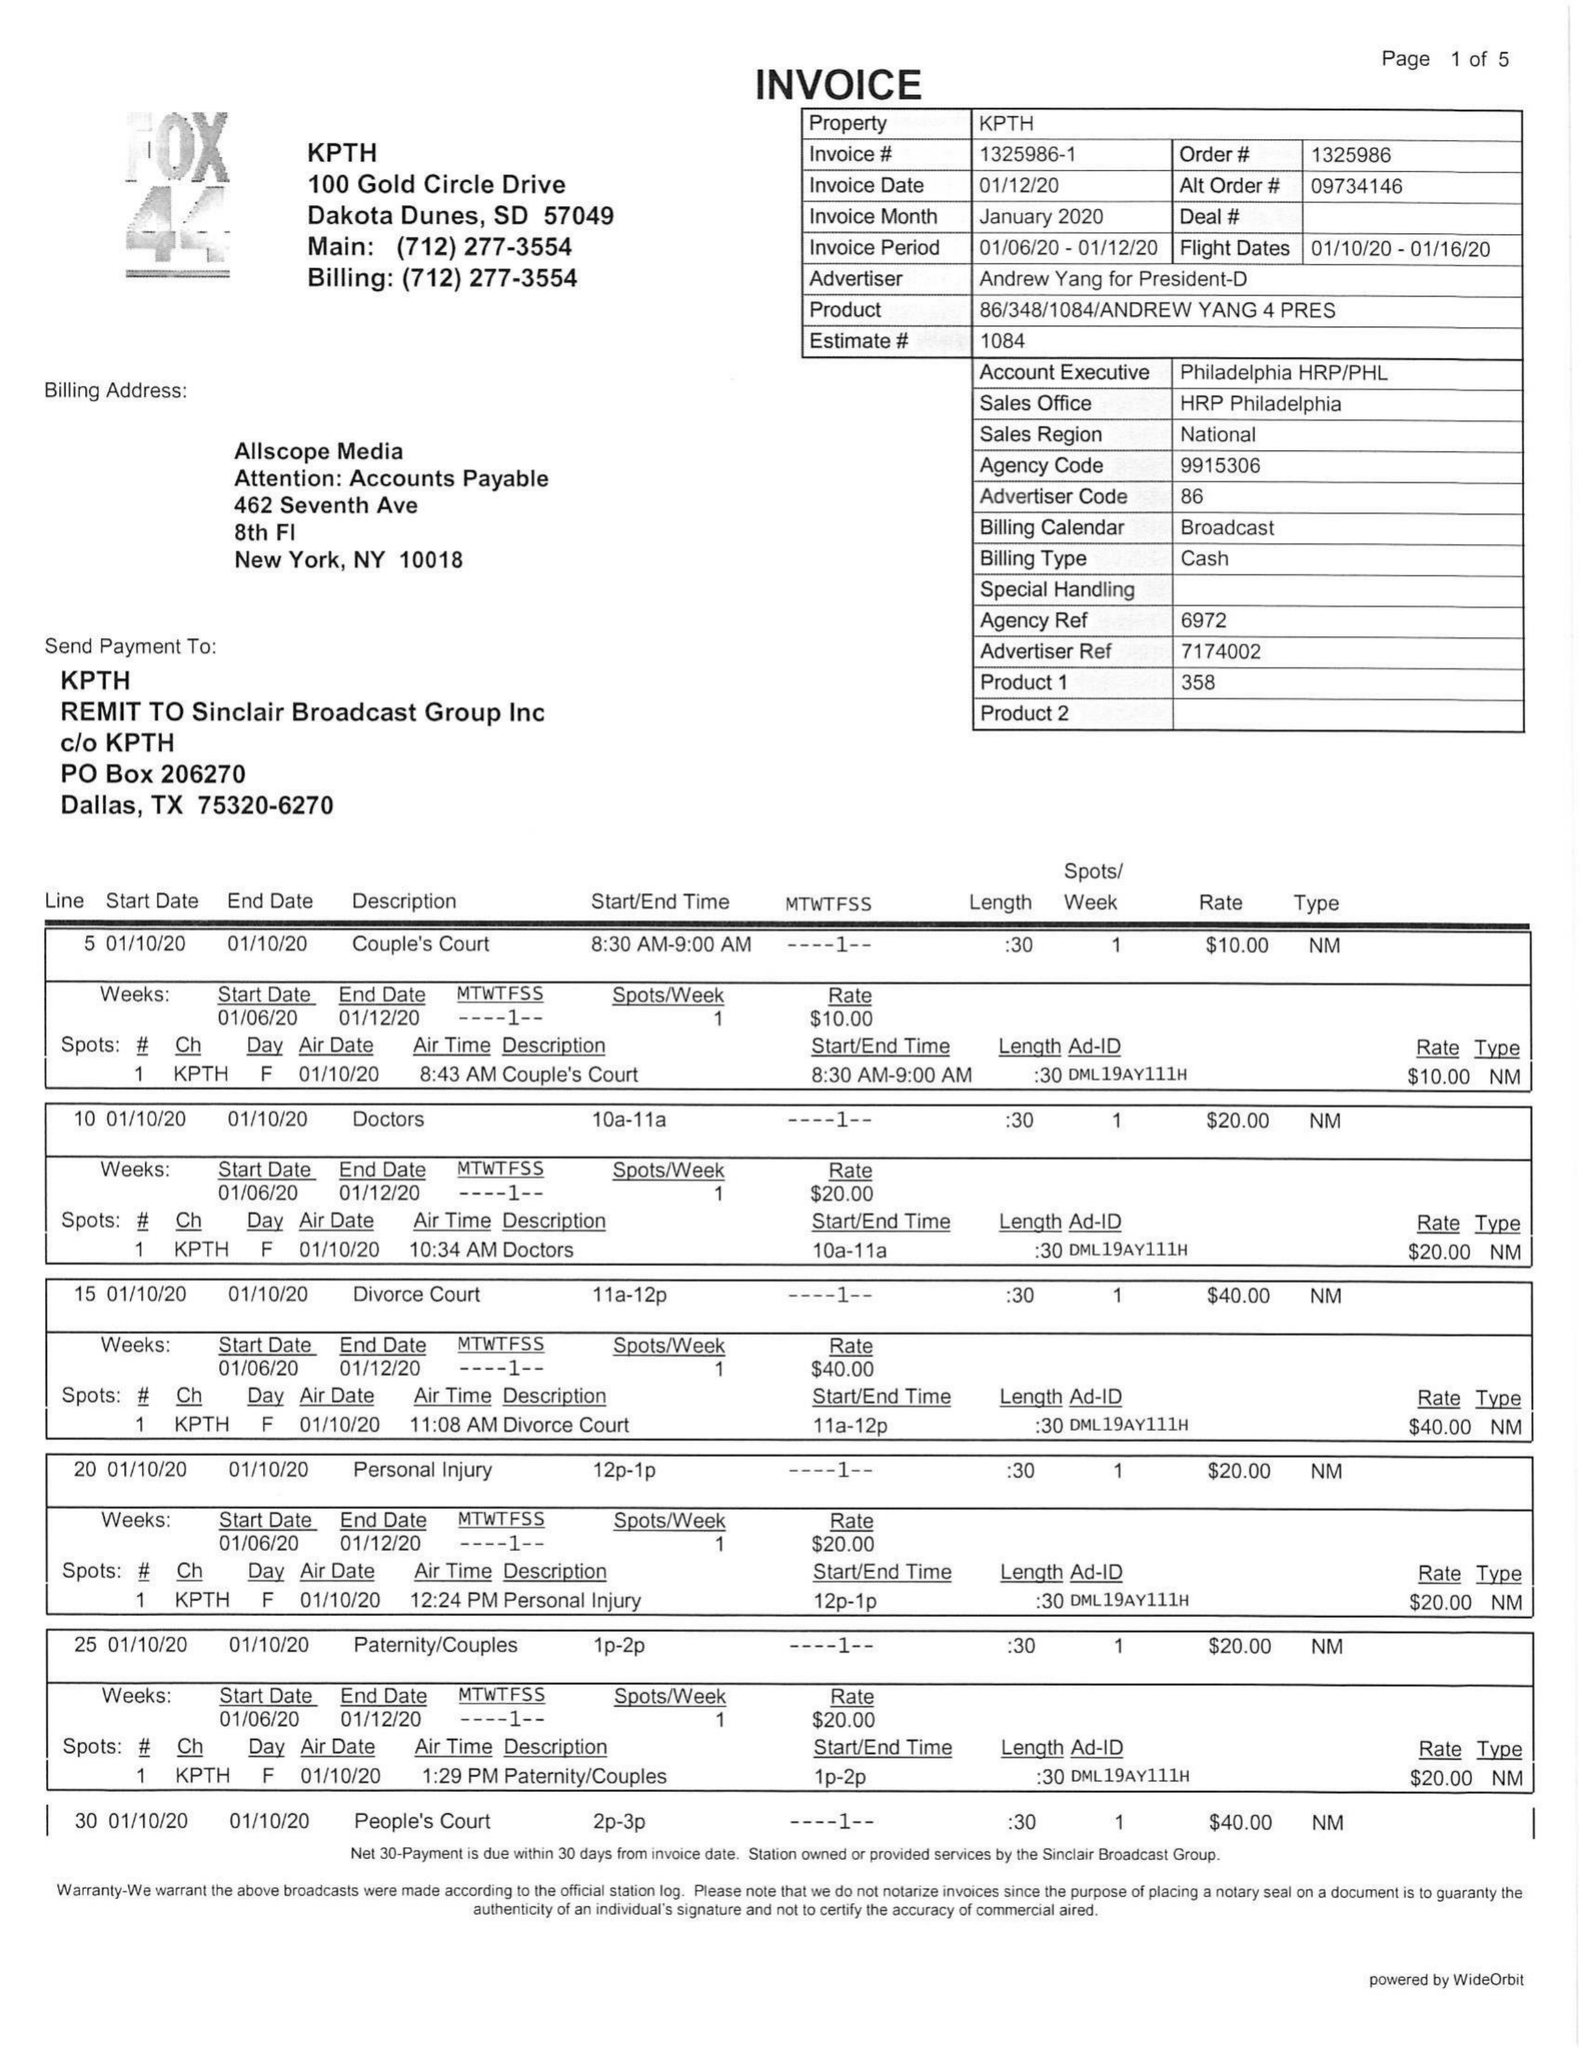What is the value for the gross_amount?
Answer the question using a single word or phrase. 1240.00 